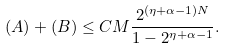Convert formula to latex. <formula><loc_0><loc_0><loc_500><loc_500>( A ) + ( B ) \leq C M \frac { 2 ^ { ( \eta + \alpha - 1 ) N } } { 1 - 2 ^ { \eta + \alpha - 1 } } .</formula> 